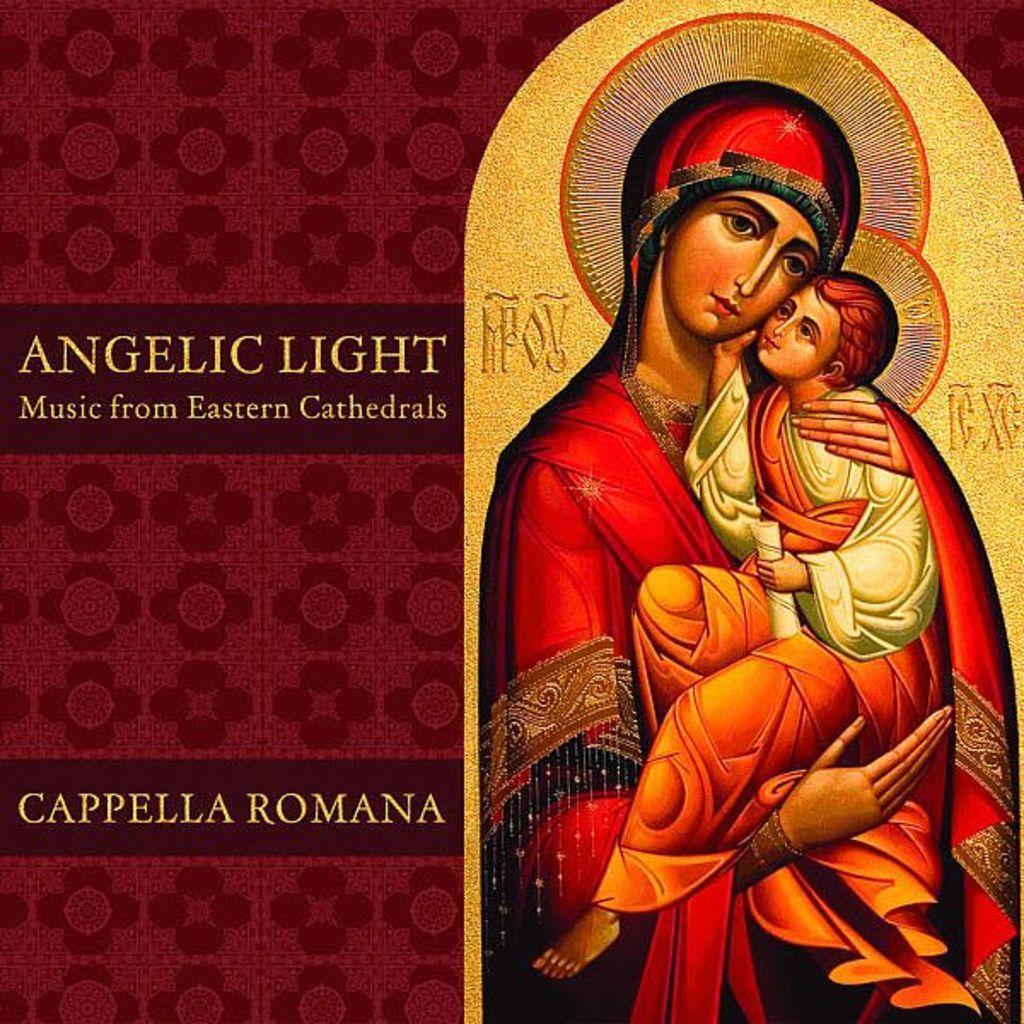Describe this image in one or two sentences. This image consists of a poster in which we can see the depiction of persons along with the text. 